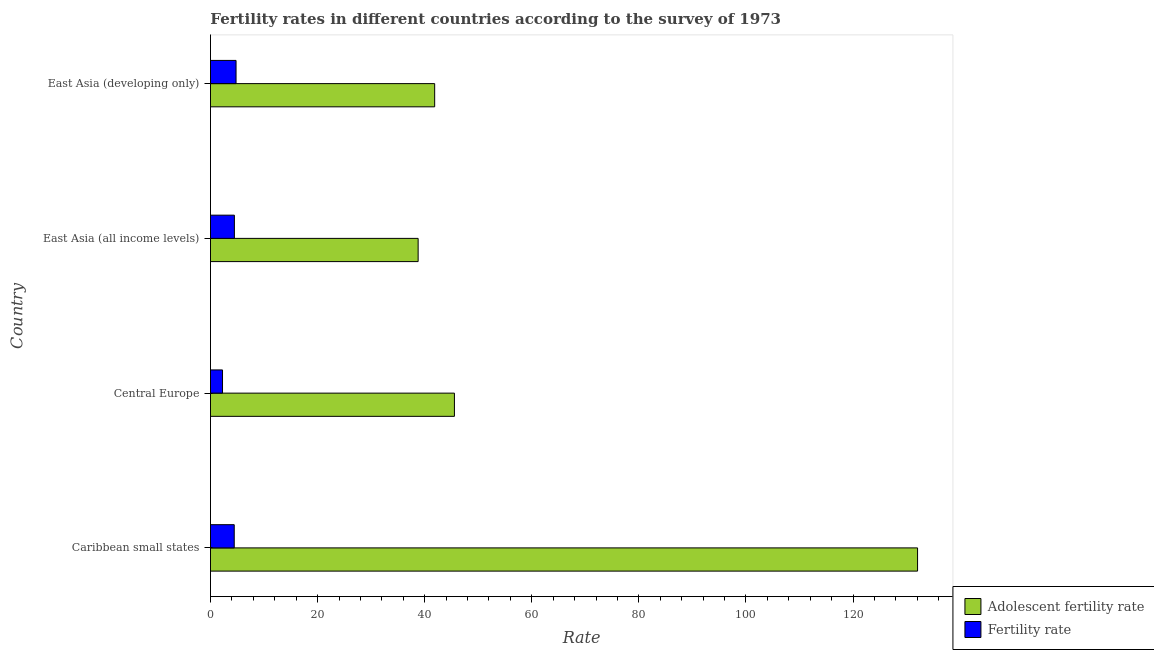How many groups of bars are there?
Your answer should be compact. 4. Are the number of bars on each tick of the Y-axis equal?
Provide a succinct answer. Yes. What is the label of the 1st group of bars from the top?
Your answer should be very brief. East Asia (developing only). What is the fertility rate in Central Europe?
Your answer should be very brief. 2.25. Across all countries, what is the maximum adolescent fertility rate?
Ensure brevity in your answer.  132.04. Across all countries, what is the minimum adolescent fertility rate?
Provide a short and direct response. 38.78. In which country was the fertility rate maximum?
Your answer should be compact. East Asia (developing only). In which country was the adolescent fertility rate minimum?
Keep it short and to the point. East Asia (all income levels). What is the total fertility rate in the graph?
Your response must be concise. 15.93. What is the difference between the fertility rate in Central Europe and that in East Asia (all income levels)?
Your answer should be compact. -2.22. What is the difference between the adolescent fertility rate in Caribbean small states and the fertility rate in East Asia (developing only)?
Keep it short and to the point. 127.26. What is the average fertility rate per country?
Ensure brevity in your answer.  3.98. What is the difference between the adolescent fertility rate and fertility rate in East Asia (developing only)?
Your answer should be compact. 37.09. In how many countries, is the fertility rate greater than 32 ?
Your answer should be very brief. 0. What is the ratio of the adolescent fertility rate in Central Europe to that in East Asia (developing only)?
Your answer should be compact. 1.09. Is the fertility rate in Caribbean small states less than that in Central Europe?
Make the answer very short. No. Is the difference between the fertility rate in Central Europe and East Asia (all income levels) greater than the difference between the adolescent fertility rate in Central Europe and East Asia (all income levels)?
Make the answer very short. No. What is the difference between the highest and the second highest fertility rate?
Your answer should be very brief. 0.31. What is the difference between the highest and the lowest adolescent fertility rate?
Make the answer very short. 93.26. In how many countries, is the fertility rate greater than the average fertility rate taken over all countries?
Make the answer very short. 3. What does the 2nd bar from the top in Caribbean small states represents?
Offer a very short reply. Adolescent fertility rate. What does the 2nd bar from the bottom in Caribbean small states represents?
Give a very brief answer. Fertility rate. How many bars are there?
Ensure brevity in your answer.  8. Does the graph contain any zero values?
Provide a succinct answer. No. Does the graph contain grids?
Your answer should be very brief. No. Where does the legend appear in the graph?
Your answer should be compact. Bottom right. How are the legend labels stacked?
Provide a succinct answer. Vertical. What is the title of the graph?
Provide a short and direct response. Fertility rates in different countries according to the survey of 1973. Does "Merchandise exports" appear as one of the legend labels in the graph?
Provide a short and direct response. No. What is the label or title of the X-axis?
Keep it short and to the point. Rate. What is the Rate in Adolescent fertility rate in Caribbean small states?
Your answer should be compact. 132.04. What is the Rate of Fertility rate in Caribbean small states?
Provide a succinct answer. 4.44. What is the Rate of Adolescent fertility rate in Central Europe?
Give a very brief answer. 45.56. What is the Rate of Fertility rate in Central Europe?
Offer a terse response. 2.25. What is the Rate in Adolescent fertility rate in East Asia (all income levels)?
Give a very brief answer. 38.78. What is the Rate of Fertility rate in East Asia (all income levels)?
Provide a succinct answer. 4.47. What is the Rate of Adolescent fertility rate in East Asia (developing only)?
Offer a very short reply. 41.87. What is the Rate in Fertility rate in East Asia (developing only)?
Provide a short and direct response. 4.78. Across all countries, what is the maximum Rate in Adolescent fertility rate?
Your answer should be very brief. 132.04. Across all countries, what is the maximum Rate in Fertility rate?
Your answer should be compact. 4.78. Across all countries, what is the minimum Rate of Adolescent fertility rate?
Offer a terse response. 38.78. Across all countries, what is the minimum Rate of Fertility rate?
Ensure brevity in your answer.  2.25. What is the total Rate in Adolescent fertility rate in the graph?
Your answer should be very brief. 258.24. What is the total Rate in Fertility rate in the graph?
Your response must be concise. 15.93. What is the difference between the Rate of Adolescent fertility rate in Caribbean small states and that in Central Europe?
Give a very brief answer. 86.49. What is the difference between the Rate in Fertility rate in Caribbean small states and that in Central Europe?
Your answer should be compact. 2.19. What is the difference between the Rate in Adolescent fertility rate in Caribbean small states and that in East Asia (all income levels)?
Make the answer very short. 93.26. What is the difference between the Rate of Fertility rate in Caribbean small states and that in East Asia (all income levels)?
Offer a very short reply. -0.03. What is the difference between the Rate of Adolescent fertility rate in Caribbean small states and that in East Asia (developing only)?
Give a very brief answer. 90.17. What is the difference between the Rate of Fertility rate in Caribbean small states and that in East Asia (developing only)?
Offer a very short reply. -0.34. What is the difference between the Rate of Adolescent fertility rate in Central Europe and that in East Asia (all income levels)?
Make the answer very short. 6.78. What is the difference between the Rate in Fertility rate in Central Europe and that in East Asia (all income levels)?
Your answer should be compact. -2.22. What is the difference between the Rate in Adolescent fertility rate in Central Europe and that in East Asia (developing only)?
Offer a terse response. 3.69. What is the difference between the Rate in Fertility rate in Central Europe and that in East Asia (developing only)?
Your response must be concise. -2.53. What is the difference between the Rate of Adolescent fertility rate in East Asia (all income levels) and that in East Asia (developing only)?
Your answer should be compact. -3.09. What is the difference between the Rate of Fertility rate in East Asia (all income levels) and that in East Asia (developing only)?
Give a very brief answer. -0.31. What is the difference between the Rate of Adolescent fertility rate in Caribbean small states and the Rate of Fertility rate in Central Europe?
Your response must be concise. 129.79. What is the difference between the Rate in Adolescent fertility rate in Caribbean small states and the Rate in Fertility rate in East Asia (all income levels)?
Offer a terse response. 127.57. What is the difference between the Rate of Adolescent fertility rate in Caribbean small states and the Rate of Fertility rate in East Asia (developing only)?
Offer a terse response. 127.26. What is the difference between the Rate in Adolescent fertility rate in Central Europe and the Rate in Fertility rate in East Asia (all income levels)?
Provide a short and direct response. 41.09. What is the difference between the Rate of Adolescent fertility rate in Central Europe and the Rate of Fertility rate in East Asia (developing only)?
Make the answer very short. 40.78. What is the difference between the Rate in Adolescent fertility rate in East Asia (all income levels) and the Rate in Fertility rate in East Asia (developing only)?
Make the answer very short. 34. What is the average Rate in Adolescent fertility rate per country?
Provide a succinct answer. 64.56. What is the average Rate of Fertility rate per country?
Give a very brief answer. 3.98. What is the difference between the Rate in Adolescent fertility rate and Rate in Fertility rate in Caribbean small states?
Offer a terse response. 127.6. What is the difference between the Rate of Adolescent fertility rate and Rate of Fertility rate in Central Europe?
Provide a short and direct response. 43.31. What is the difference between the Rate of Adolescent fertility rate and Rate of Fertility rate in East Asia (all income levels)?
Provide a succinct answer. 34.31. What is the difference between the Rate in Adolescent fertility rate and Rate in Fertility rate in East Asia (developing only)?
Give a very brief answer. 37.09. What is the ratio of the Rate in Adolescent fertility rate in Caribbean small states to that in Central Europe?
Your response must be concise. 2.9. What is the ratio of the Rate in Fertility rate in Caribbean small states to that in Central Europe?
Your answer should be very brief. 1.97. What is the ratio of the Rate in Adolescent fertility rate in Caribbean small states to that in East Asia (all income levels)?
Give a very brief answer. 3.4. What is the ratio of the Rate in Fertility rate in Caribbean small states to that in East Asia (all income levels)?
Provide a succinct answer. 0.99. What is the ratio of the Rate of Adolescent fertility rate in Caribbean small states to that in East Asia (developing only)?
Offer a terse response. 3.15. What is the ratio of the Rate in Fertility rate in Caribbean small states to that in East Asia (developing only)?
Your answer should be very brief. 0.93. What is the ratio of the Rate in Adolescent fertility rate in Central Europe to that in East Asia (all income levels)?
Give a very brief answer. 1.17. What is the ratio of the Rate in Fertility rate in Central Europe to that in East Asia (all income levels)?
Your answer should be compact. 0.5. What is the ratio of the Rate of Adolescent fertility rate in Central Europe to that in East Asia (developing only)?
Your answer should be compact. 1.09. What is the ratio of the Rate in Fertility rate in Central Europe to that in East Asia (developing only)?
Your answer should be very brief. 0.47. What is the ratio of the Rate in Adolescent fertility rate in East Asia (all income levels) to that in East Asia (developing only)?
Keep it short and to the point. 0.93. What is the ratio of the Rate in Fertility rate in East Asia (all income levels) to that in East Asia (developing only)?
Offer a very short reply. 0.94. What is the difference between the highest and the second highest Rate of Adolescent fertility rate?
Your answer should be compact. 86.49. What is the difference between the highest and the second highest Rate of Fertility rate?
Make the answer very short. 0.31. What is the difference between the highest and the lowest Rate in Adolescent fertility rate?
Provide a short and direct response. 93.26. What is the difference between the highest and the lowest Rate in Fertility rate?
Your answer should be very brief. 2.53. 